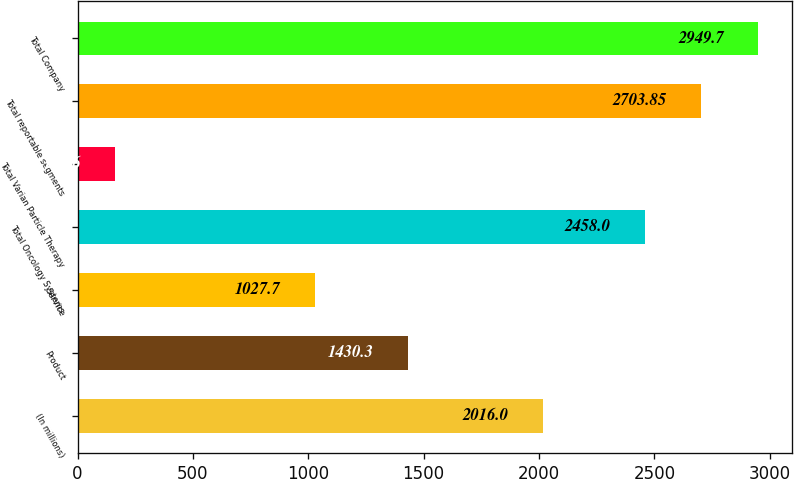<chart> <loc_0><loc_0><loc_500><loc_500><bar_chart><fcel>(In millions)<fcel>Product<fcel>Service<fcel>Total Oncology Systems<fcel>Total Varian Particle Therapy<fcel>Total reportable segments<fcel>Total Company<nl><fcel>2016<fcel>1430.3<fcel>1027.7<fcel>2458<fcel>162.6<fcel>2703.85<fcel>2949.7<nl></chart> 